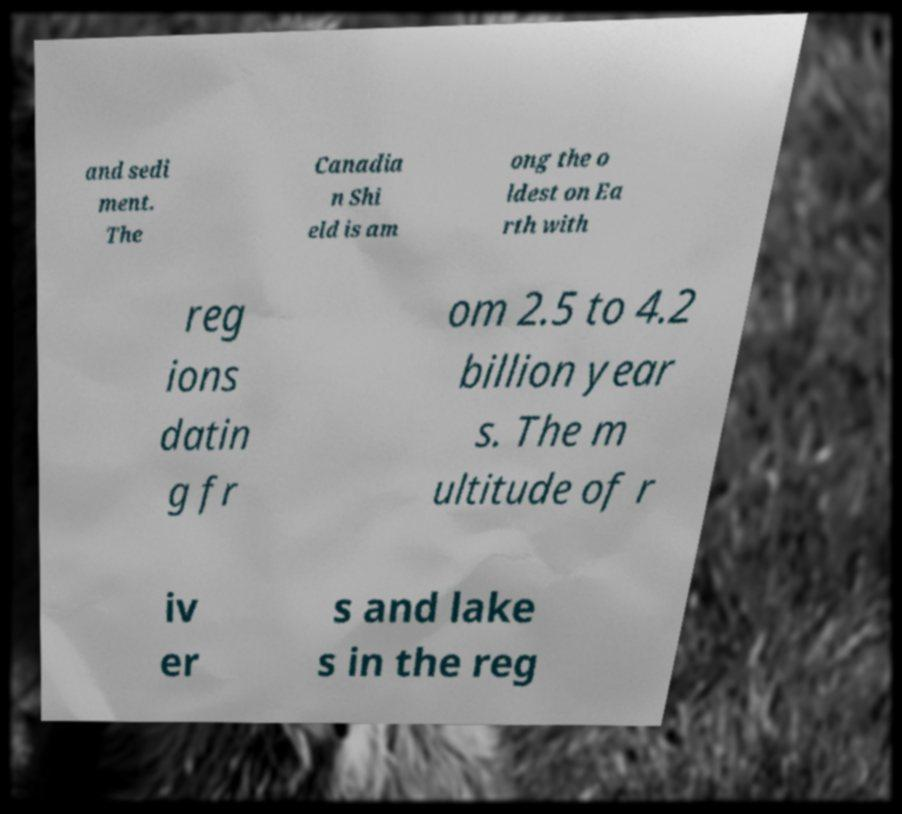There's text embedded in this image that I need extracted. Can you transcribe it verbatim? and sedi ment. The Canadia n Shi eld is am ong the o ldest on Ea rth with reg ions datin g fr om 2.5 to 4.2 billion year s. The m ultitude of r iv er s and lake s in the reg 